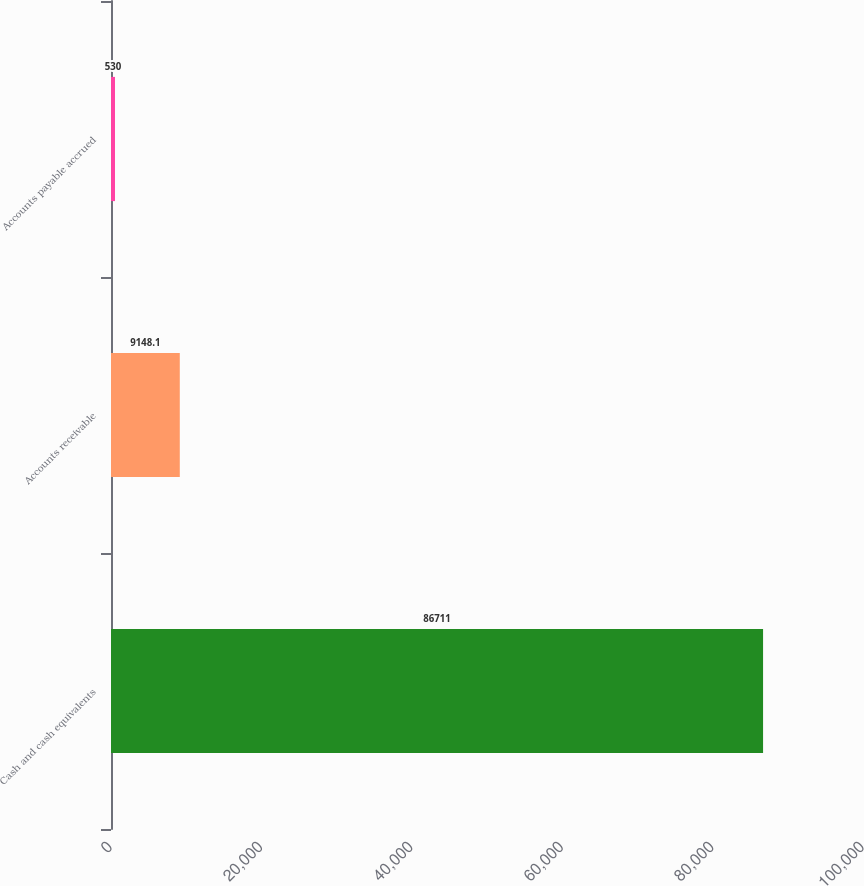<chart> <loc_0><loc_0><loc_500><loc_500><bar_chart><fcel>Cash and cash equivalents<fcel>Accounts receivable<fcel>Accounts payable accrued<nl><fcel>86711<fcel>9148.1<fcel>530<nl></chart> 